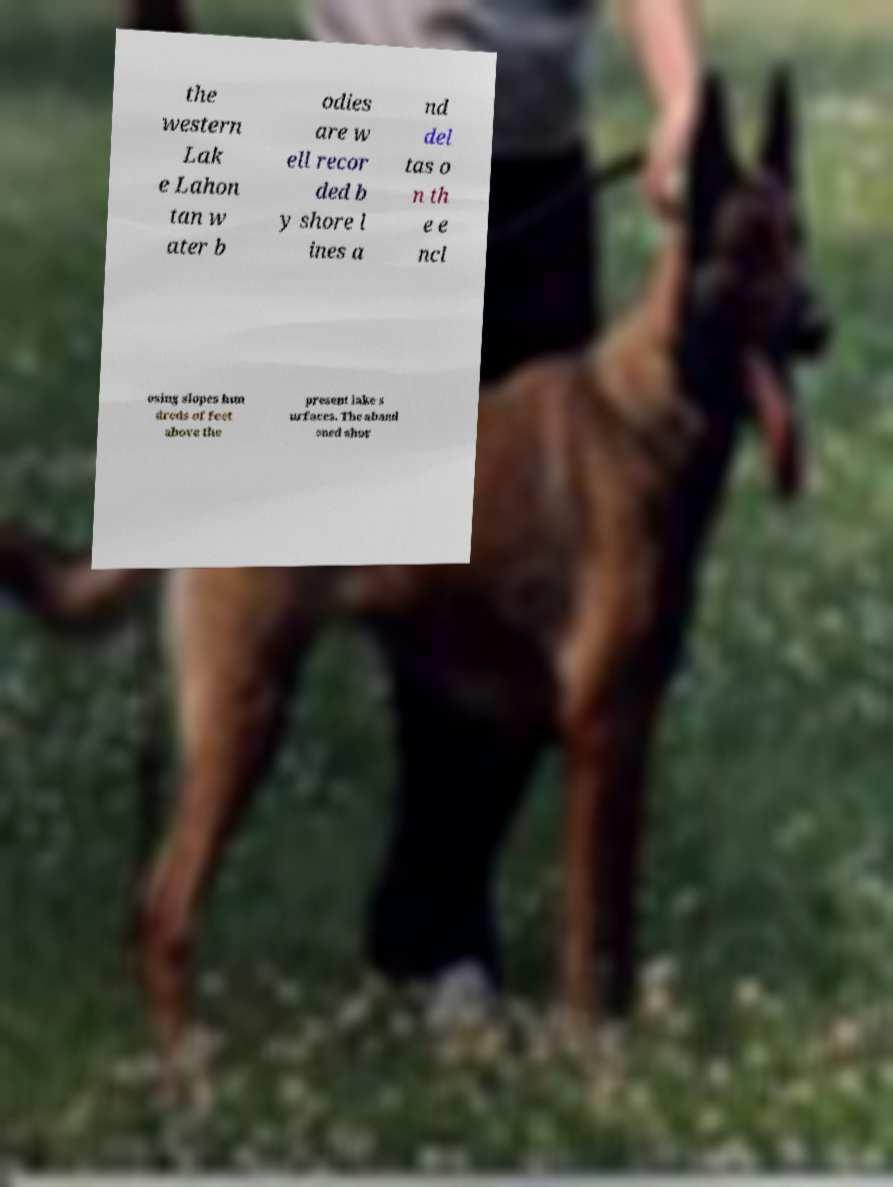I need the written content from this picture converted into text. Can you do that? the western Lak e Lahon tan w ater b odies are w ell recor ded b y shore l ines a nd del tas o n th e e ncl osing slopes hun dreds of feet above the present lake s urfaces. The aband oned shor 